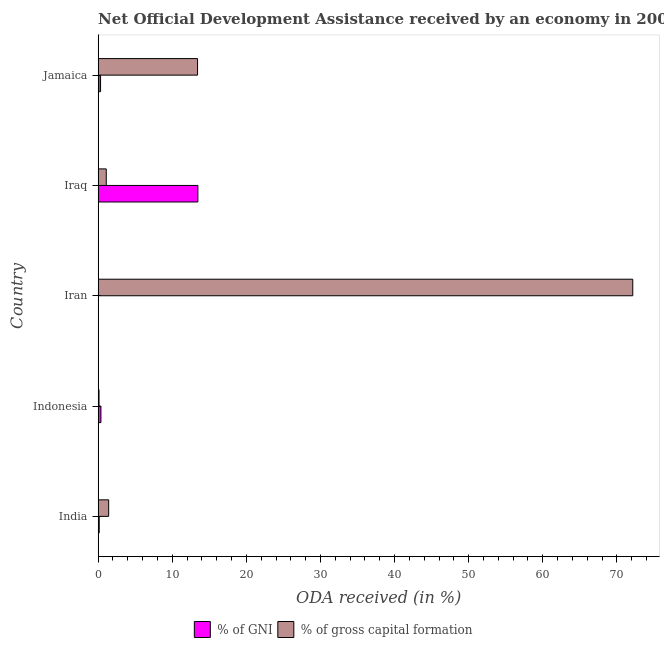Are the number of bars per tick equal to the number of legend labels?
Make the answer very short. Yes. How many bars are there on the 4th tick from the top?
Provide a short and direct response. 2. How many bars are there on the 2nd tick from the bottom?
Ensure brevity in your answer.  2. What is the label of the 2nd group of bars from the top?
Your answer should be compact. Iraq. What is the oda received as percentage of gni in Iran?
Your answer should be very brief. 0.04. Across all countries, what is the maximum oda received as percentage of gni?
Keep it short and to the point. 13.46. Across all countries, what is the minimum oda received as percentage of gni?
Keep it short and to the point. 0.04. In which country was the oda received as percentage of gni maximum?
Your answer should be very brief. Iraq. What is the total oda received as percentage of gni in the graph?
Keep it short and to the point. 14.36. What is the difference between the oda received as percentage of gross capital formation in India and that in Iran?
Offer a very short reply. -70.71. What is the difference between the oda received as percentage of gni in Jamaica and the oda received as percentage of gross capital formation in Indonesia?
Offer a very short reply. 0.21. What is the average oda received as percentage of gni per country?
Keep it short and to the point. 2.87. What is the difference between the oda received as percentage of gni and oda received as percentage of gross capital formation in Iraq?
Offer a very short reply. 12.36. In how many countries, is the oda received as percentage of gross capital formation greater than 16 %?
Provide a short and direct response. 1. What is the ratio of the oda received as percentage of gross capital formation in Indonesia to that in Iran?
Keep it short and to the point. 0. What is the difference between the highest and the second highest oda received as percentage of gni?
Your response must be concise. 13.08. What is the difference between the highest and the lowest oda received as percentage of gross capital formation?
Your answer should be compact. 72.01. Is the sum of the oda received as percentage of gni in India and Iran greater than the maximum oda received as percentage of gross capital formation across all countries?
Make the answer very short. No. What does the 2nd bar from the top in Indonesia represents?
Offer a terse response. % of GNI. What does the 2nd bar from the bottom in Iran represents?
Ensure brevity in your answer.  % of gross capital formation. Does the graph contain any zero values?
Your answer should be compact. No. What is the title of the graph?
Make the answer very short. Net Official Development Assistance received by an economy in 2006. What is the label or title of the X-axis?
Keep it short and to the point. ODA received (in %). What is the label or title of the Y-axis?
Keep it short and to the point. Country. What is the ODA received (in %) of % of GNI in India?
Offer a very short reply. 0.15. What is the ODA received (in %) of % of gross capital formation in India?
Make the answer very short. 1.42. What is the ODA received (in %) of % of GNI in Indonesia?
Your response must be concise. 0.38. What is the ODA received (in %) in % of gross capital formation in Indonesia?
Offer a terse response. 0.12. What is the ODA received (in %) in % of GNI in Iran?
Your response must be concise. 0.04. What is the ODA received (in %) of % of gross capital formation in Iran?
Provide a short and direct response. 72.14. What is the ODA received (in %) of % of GNI in Iraq?
Provide a short and direct response. 13.46. What is the ODA received (in %) of % of gross capital formation in Iraq?
Give a very brief answer. 1.1. What is the ODA received (in %) in % of GNI in Jamaica?
Your answer should be compact. 0.33. What is the ODA received (in %) in % of gross capital formation in Jamaica?
Your answer should be very brief. 13.42. Across all countries, what is the maximum ODA received (in %) of % of GNI?
Your response must be concise. 13.46. Across all countries, what is the maximum ODA received (in %) of % of gross capital formation?
Ensure brevity in your answer.  72.14. Across all countries, what is the minimum ODA received (in %) in % of GNI?
Make the answer very short. 0.04. Across all countries, what is the minimum ODA received (in %) of % of gross capital formation?
Make the answer very short. 0.12. What is the total ODA received (in %) in % of GNI in the graph?
Your response must be concise. 14.36. What is the total ODA received (in %) of % of gross capital formation in the graph?
Provide a succinct answer. 88.2. What is the difference between the ODA received (in %) in % of GNI in India and that in Indonesia?
Ensure brevity in your answer.  -0.23. What is the difference between the ODA received (in %) of % of gross capital formation in India and that in Indonesia?
Ensure brevity in your answer.  1.3. What is the difference between the ODA received (in %) of % of GNI in India and that in Iran?
Offer a terse response. 0.1. What is the difference between the ODA received (in %) in % of gross capital formation in India and that in Iran?
Keep it short and to the point. -70.71. What is the difference between the ODA received (in %) of % of GNI in India and that in Iraq?
Provide a succinct answer. -13.31. What is the difference between the ODA received (in %) in % of gross capital formation in India and that in Iraq?
Your response must be concise. 0.32. What is the difference between the ODA received (in %) in % of GNI in India and that in Jamaica?
Give a very brief answer. -0.18. What is the difference between the ODA received (in %) in % of gross capital formation in India and that in Jamaica?
Offer a terse response. -11.99. What is the difference between the ODA received (in %) of % of GNI in Indonesia and that in Iran?
Keep it short and to the point. 0.33. What is the difference between the ODA received (in %) in % of gross capital formation in Indonesia and that in Iran?
Provide a succinct answer. -72.01. What is the difference between the ODA received (in %) of % of GNI in Indonesia and that in Iraq?
Your answer should be compact. -13.08. What is the difference between the ODA received (in %) of % of gross capital formation in Indonesia and that in Iraq?
Make the answer very short. -0.97. What is the difference between the ODA received (in %) of % of GNI in Indonesia and that in Jamaica?
Give a very brief answer. 0.05. What is the difference between the ODA received (in %) of % of gross capital formation in Indonesia and that in Jamaica?
Offer a very short reply. -13.29. What is the difference between the ODA received (in %) of % of GNI in Iran and that in Iraq?
Your response must be concise. -13.42. What is the difference between the ODA received (in %) in % of gross capital formation in Iran and that in Iraq?
Provide a short and direct response. 71.04. What is the difference between the ODA received (in %) of % of GNI in Iran and that in Jamaica?
Ensure brevity in your answer.  -0.28. What is the difference between the ODA received (in %) of % of gross capital formation in Iran and that in Jamaica?
Ensure brevity in your answer.  58.72. What is the difference between the ODA received (in %) of % of GNI in Iraq and that in Jamaica?
Provide a short and direct response. 13.13. What is the difference between the ODA received (in %) in % of gross capital formation in Iraq and that in Jamaica?
Offer a very short reply. -12.32. What is the difference between the ODA received (in %) in % of GNI in India and the ODA received (in %) in % of gross capital formation in Indonesia?
Make the answer very short. 0.02. What is the difference between the ODA received (in %) of % of GNI in India and the ODA received (in %) of % of gross capital formation in Iran?
Provide a short and direct response. -71.99. What is the difference between the ODA received (in %) in % of GNI in India and the ODA received (in %) in % of gross capital formation in Iraq?
Keep it short and to the point. -0.95. What is the difference between the ODA received (in %) of % of GNI in India and the ODA received (in %) of % of gross capital formation in Jamaica?
Offer a very short reply. -13.27. What is the difference between the ODA received (in %) in % of GNI in Indonesia and the ODA received (in %) in % of gross capital formation in Iran?
Make the answer very short. -71.76. What is the difference between the ODA received (in %) in % of GNI in Indonesia and the ODA received (in %) in % of gross capital formation in Iraq?
Provide a succinct answer. -0.72. What is the difference between the ODA received (in %) in % of GNI in Indonesia and the ODA received (in %) in % of gross capital formation in Jamaica?
Provide a succinct answer. -13.04. What is the difference between the ODA received (in %) of % of GNI in Iran and the ODA received (in %) of % of gross capital formation in Iraq?
Provide a succinct answer. -1.05. What is the difference between the ODA received (in %) of % of GNI in Iran and the ODA received (in %) of % of gross capital formation in Jamaica?
Keep it short and to the point. -13.37. What is the difference between the ODA received (in %) in % of GNI in Iraq and the ODA received (in %) in % of gross capital formation in Jamaica?
Your answer should be very brief. 0.04. What is the average ODA received (in %) in % of GNI per country?
Keep it short and to the point. 2.87. What is the average ODA received (in %) of % of gross capital formation per country?
Keep it short and to the point. 17.64. What is the difference between the ODA received (in %) in % of GNI and ODA received (in %) in % of gross capital formation in India?
Provide a succinct answer. -1.28. What is the difference between the ODA received (in %) of % of GNI and ODA received (in %) of % of gross capital formation in Indonesia?
Provide a short and direct response. 0.25. What is the difference between the ODA received (in %) in % of GNI and ODA received (in %) in % of gross capital formation in Iran?
Keep it short and to the point. -72.09. What is the difference between the ODA received (in %) of % of GNI and ODA received (in %) of % of gross capital formation in Iraq?
Keep it short and to the point. 12.36. What is the difference between the ODA received (in %) in % of GNI and ODA received (in %) in % of gross capital formation in Jamaica?
Offer a terse response. -13.09. What is the ratio of the ODA received (in %) in % of GNI in India to that in Indonesia?
Provide a succinct answer. 0.39. What is the ratio of the ODA received (in %) of % of gross capital formation in India to that in Indonesia?
Provide a succinct answer. 11.48. What is the ratio of the ODA received (in %) of % of GNI in India to that in Iran?
Give a very brief answer. 3.28. What is the ratio of the ODA received (in %) of % of gross capital formation in India to that in Iran?
Provide a succinct answer. 0.02. What is the ratio of the ODA received (in %) in % of GNI in India to that in Iraq?
Keep it short and to the point. 0.01. What is the ratio of the ODA received (in %) in % of gross capital formation in India to that in Iraq?
Ensure brevity in your answer.  1.3. What is the ratio of the ODA received (in %) in % of GNI in India to that in Jamaica?
Offer a terse response. 0.45. What is the ratio of the ODA received (in %) in % of gross capital formation in India to that in Jamaica?
Your answer should be compact. 0.11. What is the ratio of the ODA received (in %) of % of GNI in Indonesia to that in Iran?
Ensure brevity in your answer.  8.44. What is the ratio of the ODA received (in %) in % of gross capital formation in Indonesia to that in Iran?
Provide a succinct answer. 0. What is the ratio of the ODA received (in %) of % of GNI in Indonesia to that in Iraq?
Give a very brief answer. 0.03. What is the ratio of the ODA received (in %) in % of gross capital formation in Indonesia to that in Iraq?
Keep it short and to the point. 0.11. What is the ratio of the ODA received (in %) of % of GNI in Indonesia to that in Jamaica?
Provide a succinct answer. 1.15. What is the ratio of the ODA received (in %) in % of gross capital formation in Indonesia to that in Jamaica?
Keep it short and to the point. 0.01. What is the ratio of the ODA received (in %) in % of GNI in Iran to that in Iraq?
Keep it short and to the point. 0. What is the ratio of the ODA received (in %) of % of gross capital formation in Iran to that in Iraq?
Ensure brevity in your answer.  65.64. What is the ratio of the ODA received (in %) of % of GNI in Iran to that in Jamaica?
Provide a succinct answer. 0.14. What is the ratio of the ODA received (in %) of % of gross capital formation in Iran to that in Jamaica?
Provide a short and direct response. 5.38. What is the ratio of the ODA received (in %) of % of GNI in Iraq to that in Jamaica?
Your answer should be compact. 40.87. What is the ratio of the ODA received (in %) of % of gross capital formation in Iraq to that in Jamaica?
Offer a terse response. 0.08. What is the difference between the highest and the second highest ODA received (in %) of % of GNI?
Ensure brevity in your answer.  13.08. What is the difference between the highest and the second highest ODA received (in %) of % of gross capital formation?
Ensure brevity in your answer.  58.72. What is the difference between the highest and the lowest ODA received (in %) of % of GNI?
Give a very brief answer. 13.42. What is the difference between the highest and the lowest ODA received (in %) in % of gross capital formation?
Your answer should be very brief. 72.01. 